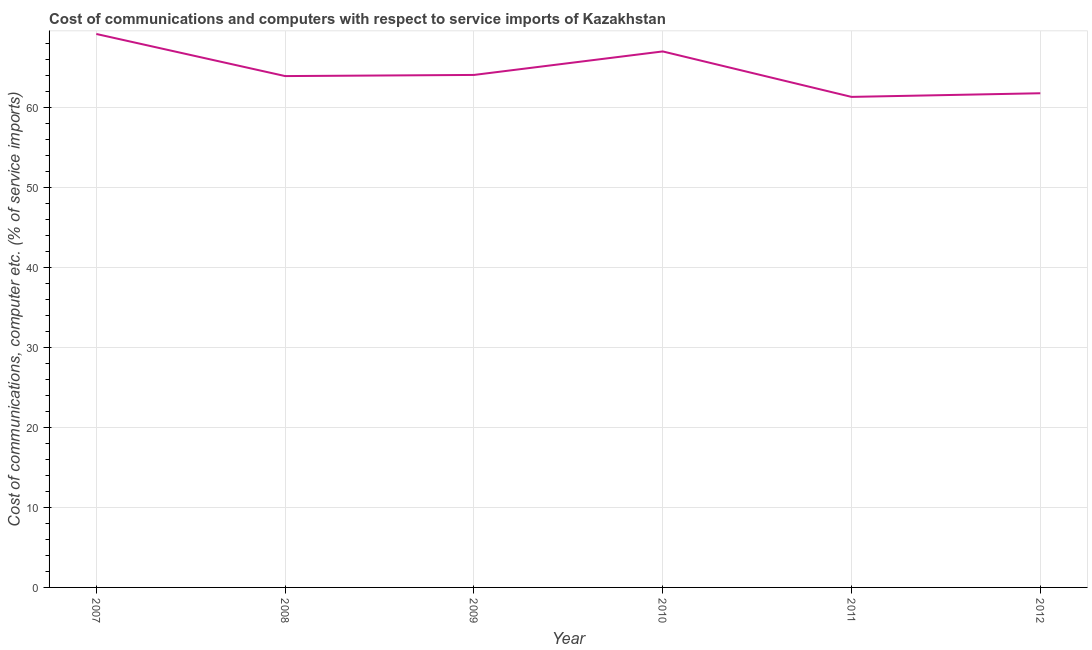What is the cost of communications and computer in 2009?
Provide a succinct answer. 64.1. Across all years, what is the maximum cost of communications and computer?
Offer a very short reply. 69.23. Across all years, what is the minimum cost of communications and computer?
Your response must be concise. 61.36. What is the sum of the cost of communications and computer?
Keep it short and to the point. 387.5. What is the difference between the cost of communications and computer in 2008 and 2010?
Make the answer very short. -3.08. What is the average cost of communications and computer per year?
Your answer should be very brief. 64.58. What is the median cost of communications and computer?
Your answer should be very brief. 64.03. In how many years, is the cost of communications and computer greater than 12 %?
Your response must be concise. 6. Do a majority of the years between 2009 and 2011 (inclusive) have cost of communications and computer greater than 16 %?
Ensure brevity in your answer.  Yes. What is the ratio of the cost of communications and computer in 2009 to that in 2012?
Offer a very short reply. 1.04. What is the difference between the highest and the second highest cost of communications and computer?
Offer a terse response. 2.18. Is the sum of the cost of communications and computer in 2008 and 2011 greater than the maximum cost of communications and computer across all years?
Your answer should be very brief. Yes. What is the difference between the highest and the lowest cost of communications and computer?
Your response must be concise. 7.87. How many lines are there?
Provide a short and direct response. 1. What is the title of the graph?
Ensure brevity in your answer.  Cost of communications and computers with respect to service imports of Kazakhstan. What is the label or title of the Y-axis?
Offer a terse response. Cost of communications, computer etc. (% of service imports). What is the Cost of communications, computer etc. (% of service imports) of 2007?
Offer a very short reply. 69.23. What is the Cost of communications, computer etc. (% of service imports) of 2008?
Your answer should be very brief. 63.96. What is the Cost of communications, computer etc. (% of service imports) in 2009?
Provide a succinct answer. 64.1. What is the Cost of communications, computer etc. (% of service imports) of 2010?
Provide a succinct answer. 67.04. What is the Cost of communications, computer etc. (% of service imports) in 2011?
Provide a succinct answer. 61.36. What is the Cost of communications, computer etc. (% of service imports) in 2012?
Your answer should be compact. 61.81. What is the difference between the Cost of communications, computer etc. (% of service imports) in 2007 and 2008?
Your answer should be compact. 5.27. What is the difference between the Cost of communications, computer etc. (% of service imports) in 2007 and 2009?
Offer a very short reply. 5.12. What is the difference between the Cost of communications, computer etc. (% of service imports) in 2007 and 2010?
Offer a terse response. 2.18. What is the difference between the Cost of communications, computer etc. (% of service imports) in 2007 and 2011?
Ensure brevity in your answer.  7.87. What is the difference between the Cost of communications, computer etc. (% of service imports) in 2007 and 2012?
Offer a very short reply. 7.41. What is the difference between the Cost of communications, computer etc. (% of service imports) in 2008 and 2009?
Give a very brief answer. -0.14. What is the difference between the Cost of communications, computer etc. (% of service imports) in 2008 and 2010?
Ensure brevity in your answer.  -3.08. What is the difference between the Cost of communications, computer etc. (% of service imports) in 2008 and 2011?
Your response must be concise. 2.6. What is the difference between the Cost of communications, computer etc. (% of service imports) in 2008 and 2012?
Give a very brief answer. 2.15. What is the difference between the Cost of communications, computer etc. (% of service imports) in 2009 and 2010?
Your answer should be compact. -2.94. What is the difference between the Cost of communications, computer etc. (% of service imports) in 2009 and 2011?
Offer a very short reply. 2.75. What is the difference between the Cost of communications, computer etc. (% of service imports) in 2009 and 2012?
Provide a short and direct response. 2.29. What is the difference between the Cost of communications, computer etc. (% of service imports) in 2010 and 2011?
Ensure brevity in your answer.  5.69. What is the difference between the Cost of communications, computer etc. (% of service imports) in 2010 and 2012?
Ensure brevity in your answer.  5.23. What is the difference between the Cost of communications, computer etc. (% of service imports) in 2011 and 2012?
Give a very brief answer. -0.46. What is the ratio of the Cost of communications, computer etc. (% of service imports) in 2007 to that in 2008?
Your answer should be very brief. 1.08. What is the ratio of the Cost of communications, computer etc. (% of service imports) in 2007 to that in 2009?
Your answer should be very brief. 1.08. What is the ratio of the Cost of communications, computer etc. (% of service imports) in 2007 to that in 2010?
Your response must be concise. 1.03. What is the ratio of the Cost of communications, computer etc. (% of service imports) in 2007 to that in 2011?
Your answer should be very brief. 1.13. What is the ratio of the Cost of communications, computer etc. (% of service imports) in 2007 to that in 2012?
Make the answer very short. 1.12. What is the ratio of the Cost of communications, computer etc. (% of service imports) in 2008 to that in 2010?
Make the answer very short. 0.95. What is the ratio of the Cost of communications, computer etc. (% of service imports) in 2008 to that in 2011?
Make the answer very short. 1.04. What is the ratio of the Cost of communications, computer etc. (% of service imports) in 2008 to that in 2012?
Ensure brevity in your answer.  1.03. What is the ratio of the Cost of communications, computer etc. (% of service imports) in 2009 to that in 2010?
Your answer should be very brief. 0.96. What is the ratio of the Cost of communications, computer etc. (% of service imports) in 2009 to that in 2011?
Offer a very short reply. 1.04. What is the ratio of the Cost of communications, computer etc. (% of service imports) in 2009 to that in 2012?
Your answer should be very brief. 1.04. What is the ratio of the Cost of communications, computer etc. (% of service imports) in 2010 to that in 2011?
Your answer should be very brief. 1.09. What is the ratio of the Cost of communications, computer etc. (% of service imports) in 2010 to that in 2012?
Keep it short and to the point. 1.08. 